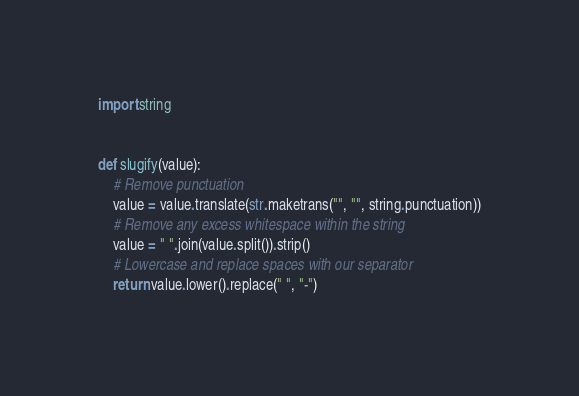<code> <loc_0><loc_0><loc_500><loc_500><_Python_>import string


def slugify(value):
    # Remove punctuation
    value = value.translate(str.maketrans("", "", string.punctuation))
    # Remove any excess whitespace within the string
    value = " ".join(value.split()).strip()
    # Lowercase and replace spaces with our separator
    return value.lower().replace(" ", "-")
</code> 